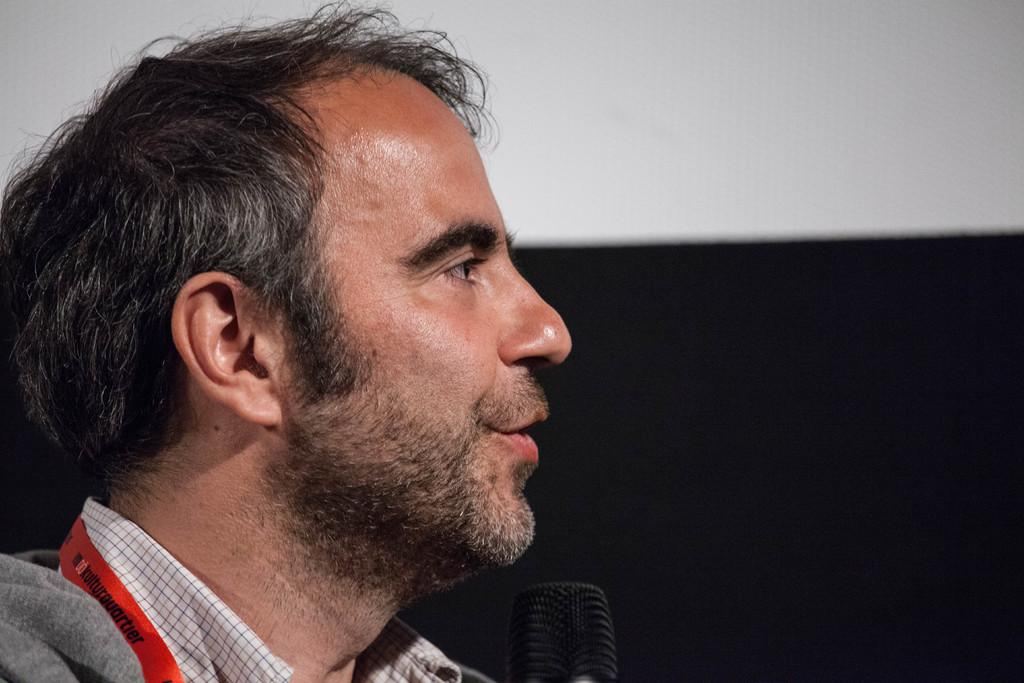Who is the main subject in the foreground of the image? There is a man in the foreground of the image. Where is the man positioned in the image? The man is on the left side of the image. What object is in front of the man? There is a mic in front of the man. Can you describe the background of the image? The background of the image is not clear. What type of parent is depicted in the image? There is no parent depicted in the image; it features a man with a mic in front of him. What kind of beam is supporting the earth in the image? There is no beam or earth present in the image. 